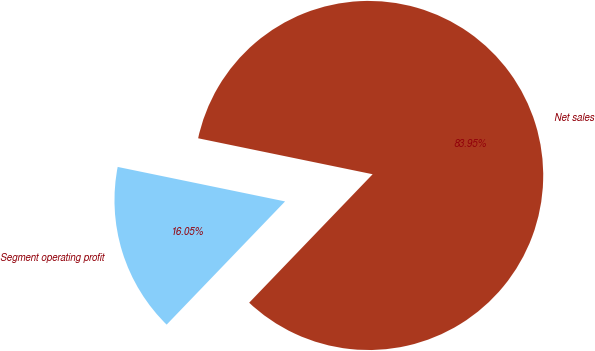Convert chart. <chart><loc_0><loc_0><loc_500><loc_500><pie_chart><fcel>Net sales<fcel>Segment operating profit<nl><fcel>83.95%<fcel>16.05%<nl></chart> 